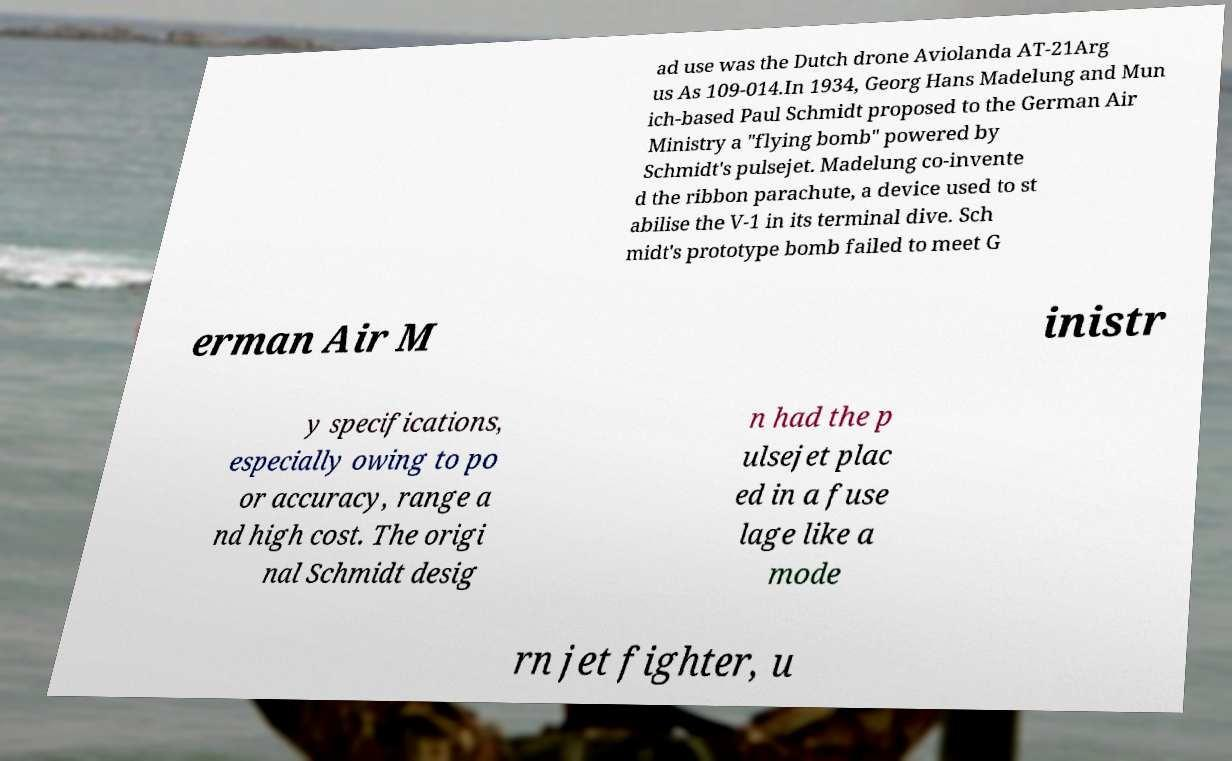There's text embedded in this image that I need extracted. Can you transcribe it verbatim? ad use was the Dutch drone Aviolanda AT-21Arg us As 109-014.In 1934, Georg Hans Madelung and Mun ich-based Paul Schmidt proposed to the German Air Ministry a "flying bomb" powered by Schmidt's pulsejet. Madelung co-invente d the ribbon parachute, a device used to st abilise the V-1 in its terminal dive. Sch midt's prototype bomb failed to meet G erman Air M inistr y specifications, especially owing to po or accuracy, range a nd high cost. The origi nal Schmidt desig n had the p ulsejet plac ed in a fuse lage like a mode rn jet fighter, u 